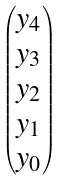<formula> <loc_0><loc_0><loc_500><loc_500>\begin{pmatrix} y _ { 4 } \\ y _ { 3 } \\ y _ { 2 } \\ y _ { 1 } \\ y _ { 0 } \end{pmatrix}</formula> 